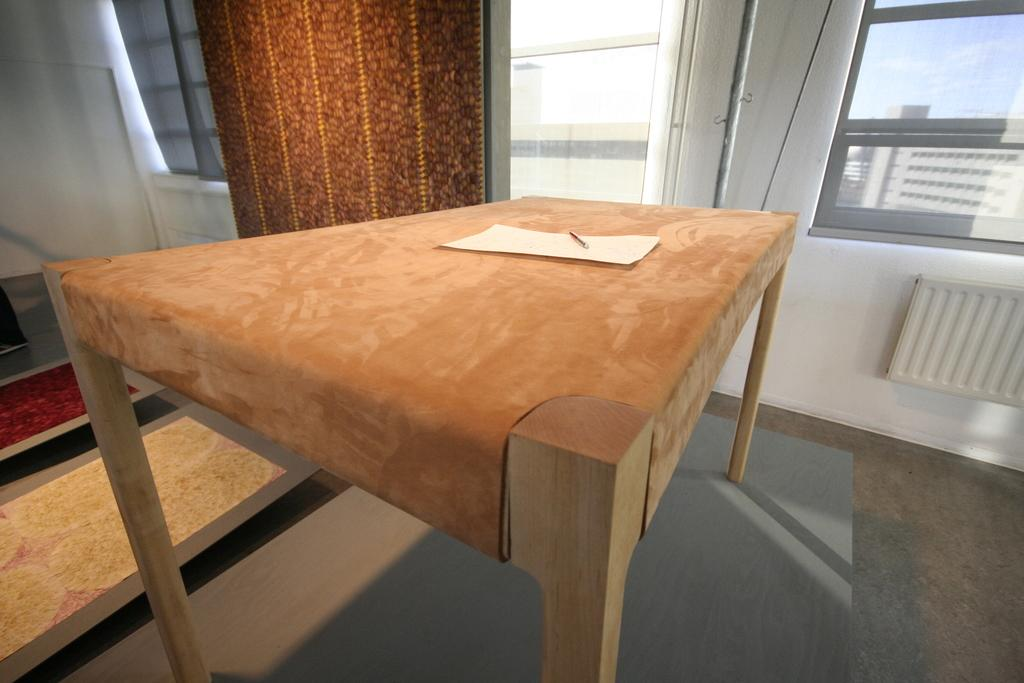What is present on the table in the image? There is a paper and a pen on the table in the image. What can be seen on the right side of the image? There is a window on the right side of the image. How many men with wings made of flesh are visible in the image? There are no men, wings, or flesh present in the image. 